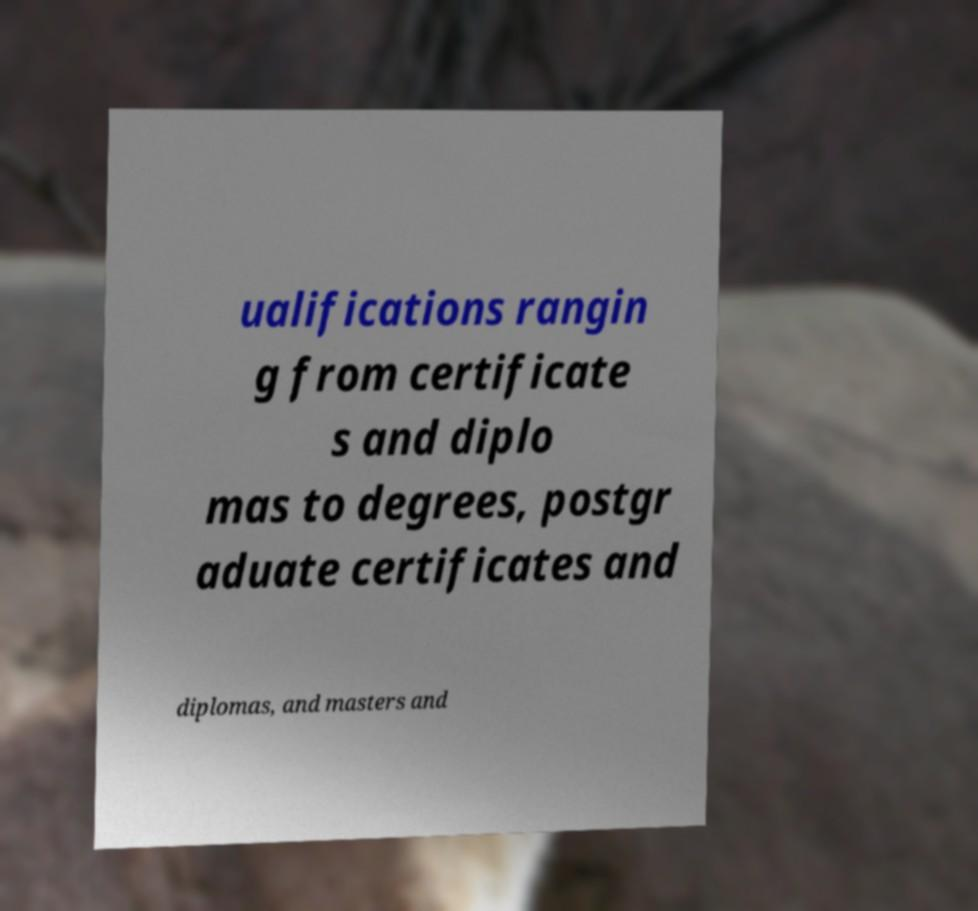Could you extract and type out the text from this image? ualifications rangin g from certificate s and diplo mas to degrees, postgr aduate certificates and diplomas, and masters and 